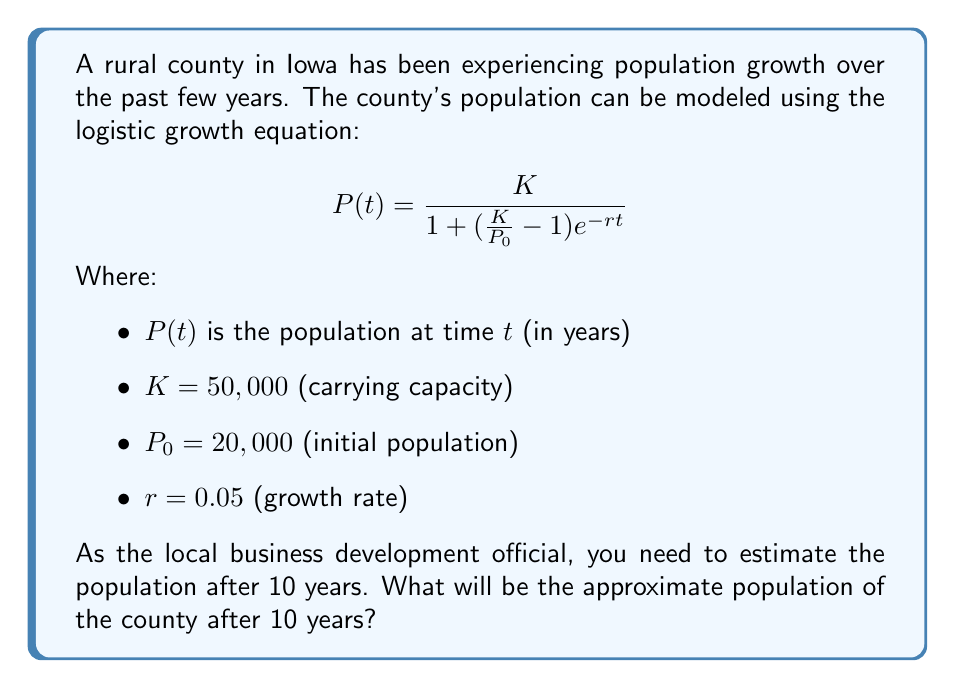What is the answer to this math problem? To solve this problem, we'll follow these steps:

1. We have the logistic growth equation:
   $$P(t) = \frac{K}{1 + (\frac{K}{P_0} - 1)e^{-rt}}$$

2. We're given the following values:
   $K = 50,000$
   $P_0 = 20,000$
   $r = 0.05$
   $t = 10$ years

3. Let's substitute these values into the equation:
   $$P(10) = \frac{50,000}{1 + (\frac{50,000}{20,000} - 1)e^{-0.05(10)}}$$

4. Simplify the fraction inside the parentheses:
   $$P(10) = \frac{50,000}{1 + (2.5 - 1)e^{-0.5}}$$

5. Simplify further:
   $$P(10) = \frac{50,000}{1 + 1.5e^{-0.5}}$$

6. Calculate $e^{-0.5}$:
   $$e^{-0.5} \approx 0.6065$$

7. Substitute this value:
   $$P(10) = \frac{50,000}{1 + 1.5(0.6065)}$$

8. Calculate the denominator:
   $$P(10) = \frac{50,000}{1 + 0.9098} = \frac{50,000}{1.9098}$$

9. Divide to get the final result:
   $$P(10) \approx 26,181$$

Therefore, after 10 years, the population of the county will be approximately 26,181 people.
Answer: 26,181 people 